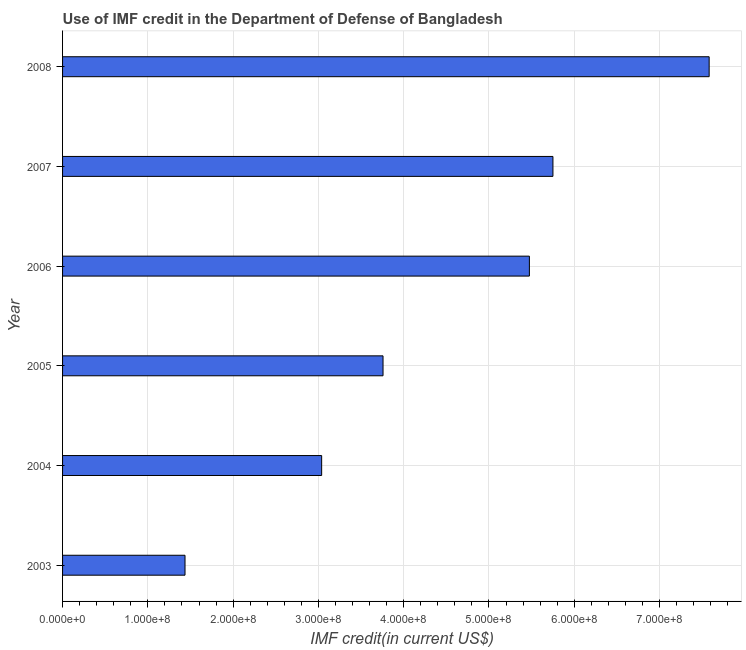What is the title of the graph?
Offer a terse response. Use of IMF credit in the Department of Defense of Bangladesh. What is the label or title of the X-axis?
Your answer should be very brief. IMF credit(in current US$). What is the label or title of the Y-axis?
Your response must be concise. Year. What is the use of imf credit in dod in 2006?
Your response must be concise. 5.47e+08. Across all years, what is the maximum use of imf credit in dod?
Provide a succinct answer. 7.58e+08. Across all years, what is the minimum use of imf credit in dod?
Provide a succinct answer. 1.44e+08. In which year was the use of imf credit in dod maximum?
Offer a terse response. 2008. In which year was the use of imf credit in dod minimum?
Offer a terse response. 2003. What is the sum of the use of imf credit in dod?
Your answer should be very brief. 2.70e+09. What is the difference between the use of imf credit in dod in 2004 and 2007?
Your answer should be compact. -2.71e+08. What is the average use of imf credit in dod per year?
Your answer should be compact. 4.51e+08. What is the median use of imf credit in dod?
Keep it short and to the point. 4.62e+08. Do a majority of the years between 2008 and 2006 (inclusive) have use of imf credit in dod greater than 280000000 US$?
Keep it short and to the point. Yes. What is the ratio of the use of imf credit in dod in 2003 to that in 2008?
Your answer should be very brief. 0.19. Is the difference between the use of imf credit in dod in 2004 and 2005 greater than the difference between any two years?
Your response must be concise. No. What is the difference between the highest and the second highest use of imf credit in dod?
Make the answer very short. 1.83e+08. What is the difference between the highest and the lowest use of imf credit in dod?
Provide a succinct answer. 6.15e+08. In how many years, is the use of imf credit in dod greater than the average use of imf credit in dod taken over all years?
Your answer should be very brief. 3. Are the values on the major ticks of X-axis written in scientific E-notation?
Make the answer very short. Yes. What is the IMF credit(in current US$) of 2003?
Offer a very short reply. 1.44e+08. What is the IMF credit(in current US$) in 2004?
Make the answer very short. 3.04e+08. What is the IMF credit(in current US$) in 2005?
Offer a very short reply. 3.76e+08. What is the IMF credit(in current US$) of 2006?
Offer a very short reply. 5.47e+08. What is the IMF credit(in current US$) in 2007?
Your response must be concise. 5.75e+08. What is the IMF credit(in current US$) in 2008?
Offer a very short reply. 7.58e+08. What is the difference between the IMF credit(in current US$) in 2003 and 2004?
Provide a short and direct response. -1.60e+08. What is the difference between the IMF credit(in current US$) in 2003 and 2005?
Your answer should be very brief. -2.32e+08. What is the difference between the IMF credit(in current US$) in 2003 and 2006?
Your response must be concise. -4.04e+08. What is the difference between the IMF credit(in current US$) in 2003 and 2007?
Provide a succinct answer. -4.31e+08. What is the difference between the IMF credit(in current US$) in 2003 and 2008?
Offer a very short reply. -6.15e+08. What is the difference between the IMF credit(in current US$) in 2004 and 2005?
Your response must be concise. -7.20e+07. What is the difference between the IMF credit(in current US$) in 2004 and 2006?
Make the answer very short. -2.44e+08. What is the difference between the IMF credit(in current US$) in 2004 and 2007?
Offer a terse response. -2.71e+08. What is the difference between the IMF credit(in current US$) in 2004 and 2008?
Your response must be concise. -4.54e+08. What is the difference between the IMF credit(in current US$) in 2005 and 2006?
Ensure brevity in your answer.  -1.72e+08. What is the difference between the IMF credit(in current US$) in 2005 and 2007?
Offer a very short reply. -1.99e+08. What is the difference between the IMF credit(in current US$) in 2005 and 2008?
Provide a short and direct response. -3.82e+08. What is the difference between the IMF credit(in current US$) in 2006 and 2007?
Give a very brief answer. -2.76e+07. What is the difference between the IMF credit(in current US$) in 2006 and 2008?
Provide a short and direct response. -2.11e+08. What is the difference between the IMF credit(in current US$) in 2007 and 2008?
Provide a short and direct response. -1.83e+08. What is the ratio of the IMF credit(in current US$) in 2003 to that in 2004?
Your response must be concise. 0.47. What is the ratio of the IMF credit(in current US$) in 2003 to that in 2005?
Give a very brief answer. 0.38. What is the ratio of the IMF credit(in current US$) in 2003 to that in 2006?
Provide a succinct answer. 0.26. What is the ratio of the IMF credit(in current US$) in 2003 to that in 2008?
Give a very brief answer. 0.19. What is the ratio of the IMF credit(in current US$) in 2004 to that in 2005?
Ensure brevity in your answer.  0.81. What is the ratio of the IMF credit(in current US$) in 2004 to that in 2006?
Your answer should be very brief. 0.56. What is the ratio of the IMF credit(in current US$) in 2004 to that in 2007?
Make the answer very short. 0.53. What is the ratio of the IMF credit(in current US$) in 2004 to that in 2008?
Keep it short and to the point. 0.4. What is the ratio of the IMF credit(in current US$) in 2005 to that in 2006?
Ensure brevity in your answer.  0.69. What is the ratio of the IMF credit(in current US$) in 2005 to that in 2007?
Your answer should be very brief. 0.65. What is the ratio of the IMF credit(in current US$) in 2005 to that in 2008?
Your response must be concise. 0.5. What is the ratio of the IMF credit(in current US$) in 2006 to that in 2007?
Provide a succinct answer. 0.95. What is the ratio of the IMF credit(in current US$) in 2006 to that in 2008?
Your response must be concise. 0.72. What is the ratio of the IMF credit(in current US$) in 2007 to that in 2008?
Offer a terse response. 0.76. 